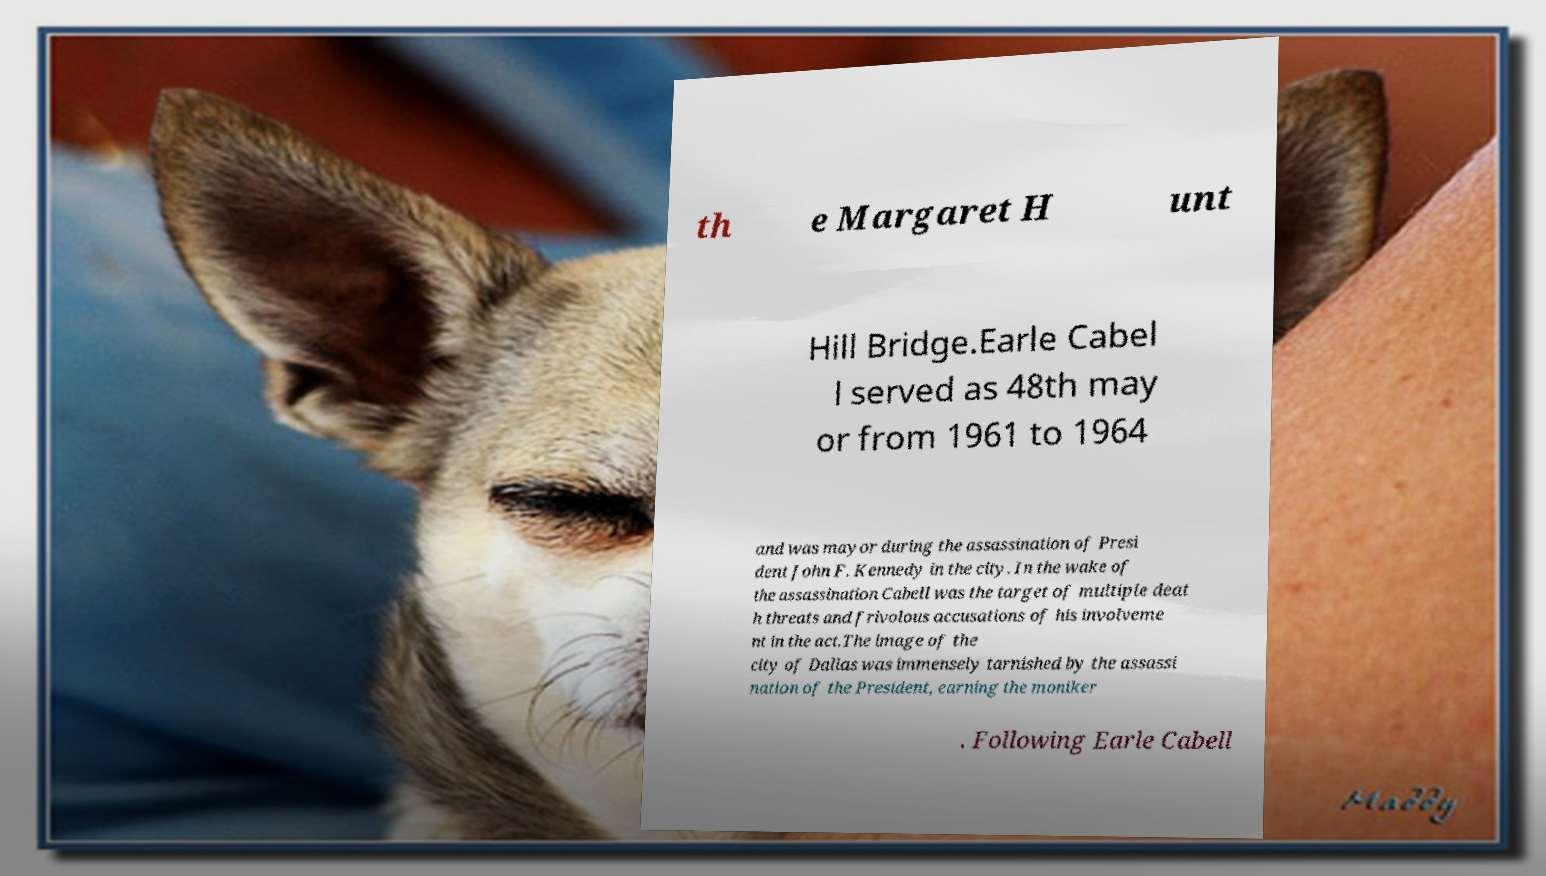Could you assist in decoding the text presented in this image and type it out clearly? th e Margaret H unt Hill Bridge.Earle Cabel l served as 48th may or from 1961 to 1964 and was mayor during the assassination of Presi dent John F. Kennedy in the city. In the wake of the assassination Cabell was the target of multiple deat h threats and frivolous accusations of his involveme nt in the act.The image of the city of Dallas was immensely tarnished by the assassi nation of the President, earning the moniker . Following Earle Cabell 